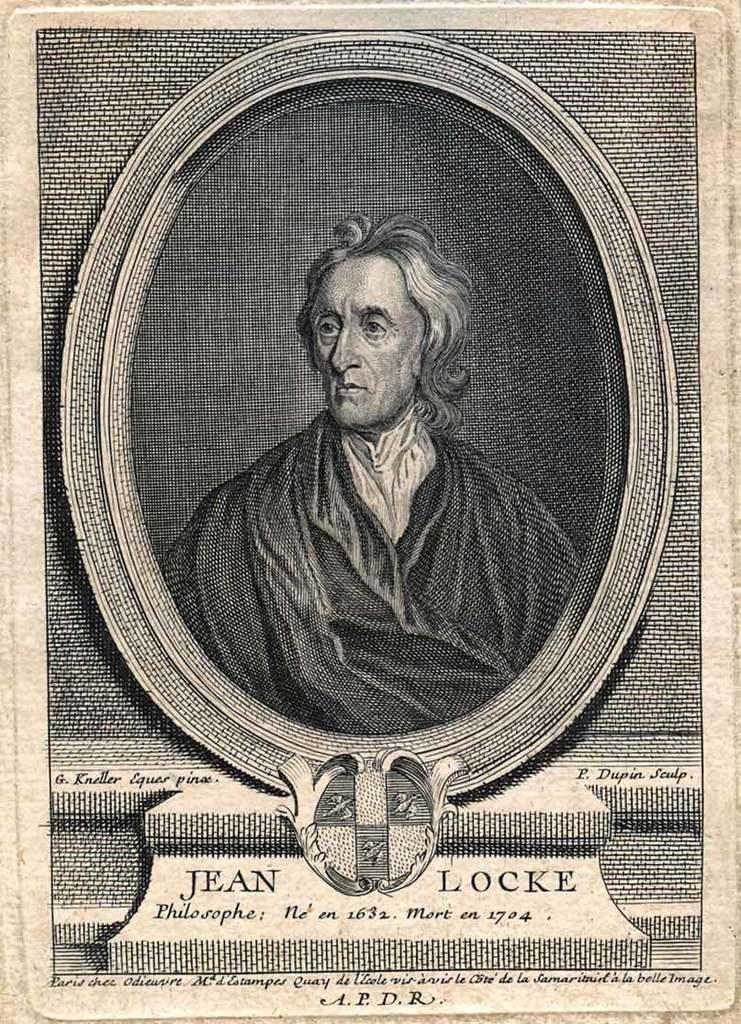<image>
Write a terse but informative summary of the picture. A close up black and white portrait of Jean Locke. 